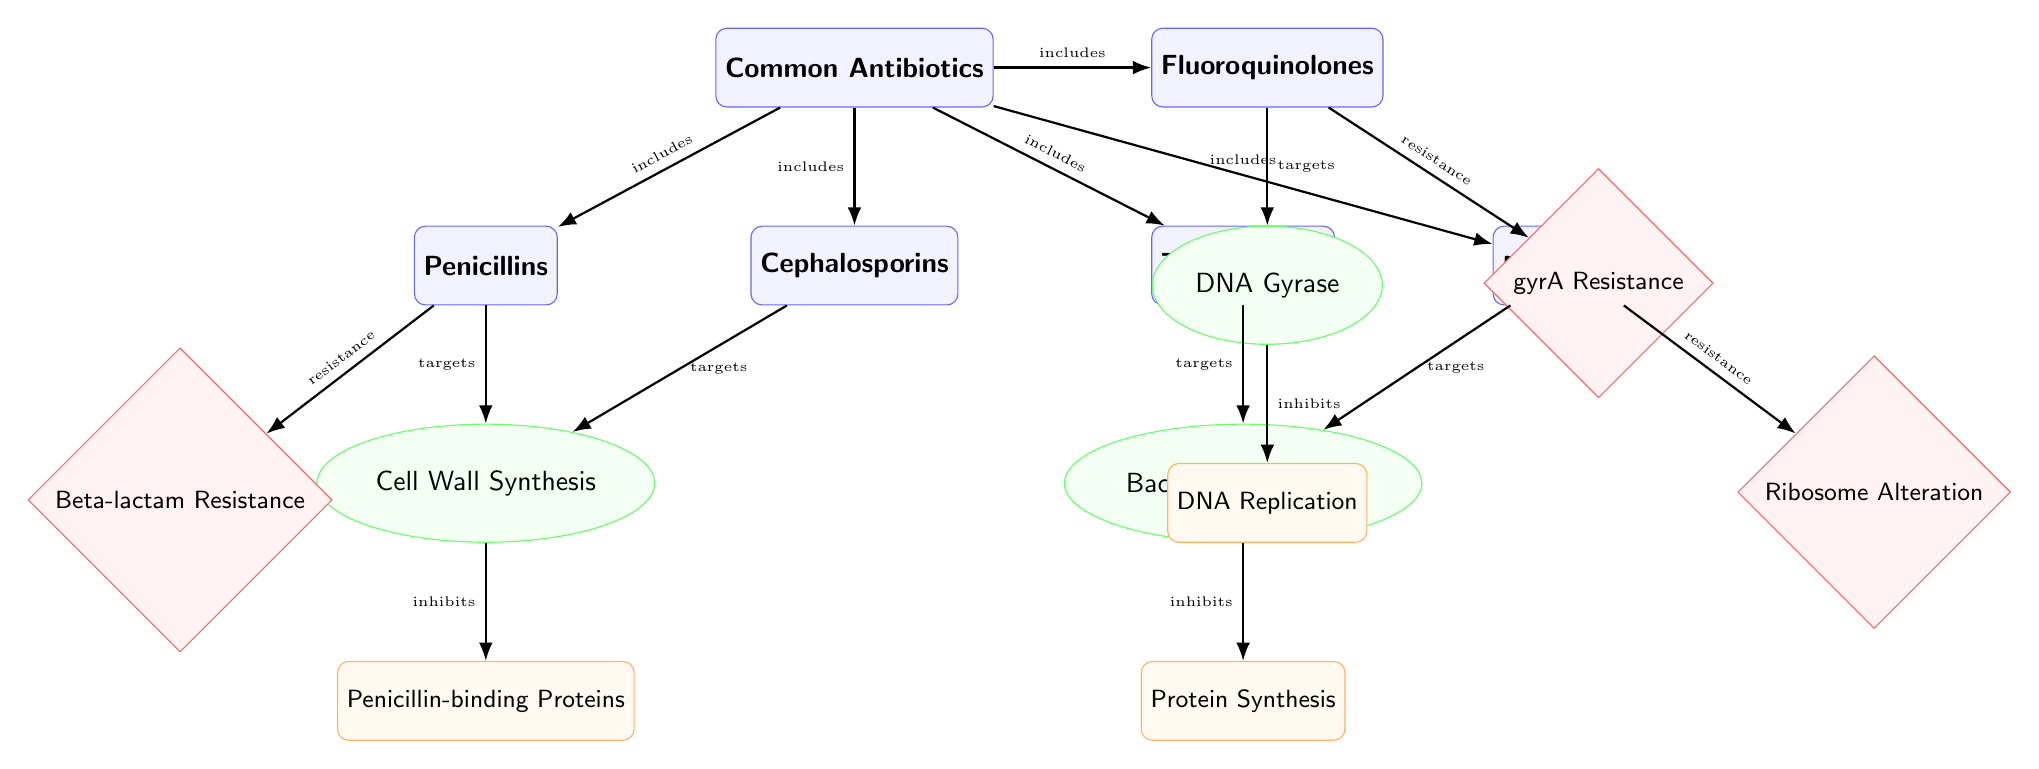What are the five common antibiotics listed in the diagram? The diagram identifies five common antibiotics: Penicillins, Cephalosporins, Tetracyclines, Macrolides, and Fluoroquinolones.
Answer: Penicillins, Cephalosporins, Tetracyclines, Macrolides, Fluoroquinolones Which two antibiotics target cell wall synthesis? The antibiotics targeting cell wall synthesis are Penicillins and Cephalosporins, as indicated by the arrows connecting them to the cell wall synthesis node.
Answer: Penicillins, Cephalosporins What process do tetracyclines inhibit? The diagram shows that Tetracyclines inhibit the process of protein synthesis, as the arrow points from bacterial ribosomes to the protein synthesis process.
Answer: Protein Synthesis How many types of resistance pathways are indicated in the diagram? There are three resistance pathways indicated in the diagram: Beta-lactam Resistance, Ribosome Alteration, and gyrA Resistance. The count can be verified by identifying each diamond-shaped node labeled with resistance.
Answer: 3 Which antibiotic exhibits gyrA resistance? The diagram clearly connects Fluoroquinolones to the gyrA Resistance node, indicating that Fluoroquinolones exhibit this type of resistance.
Answer: Fluoroquinolones What is the relationship between bacterial ribosomes and protein synthesis? The relationship shows that bacterial ribosomes are responsible for inhibiting protein synthesis, as described by the arrow drawn from bacterial ribosomes to the process of protein synthesis.
Answer: Inhibits Which two processes are linked to the targets of antibiotics? The processes linked to the targets are Penicillin-binding Proteins for cell wall synthesis and DNA Replication for DNA Gyrase, as indicated by the respective arrows leading to these processes from their targets.
Answer: Cell Wall Synthesis, DNA Replication What do macrolides target? The diagram indicates that macrolides target bacterial ribosomes, as demonstrated by the direct arrow connecting macrolides to the bacterial ribosomes node.
Answer: Bacterial Ribosomes Which antibiotics are included under common antibiotics? The common antibiotics are grouped together under a single node. The specific antibiotics included are Penicillins, Cephalosporins, Tetracyclines, Macrolides, and Fluoroquinolones as shown in the lower portion of the overall diagram structure.
Answer: Penicillins, Cephalosporins, Tetracyclines, Macrolides, Fluoroquinolones 